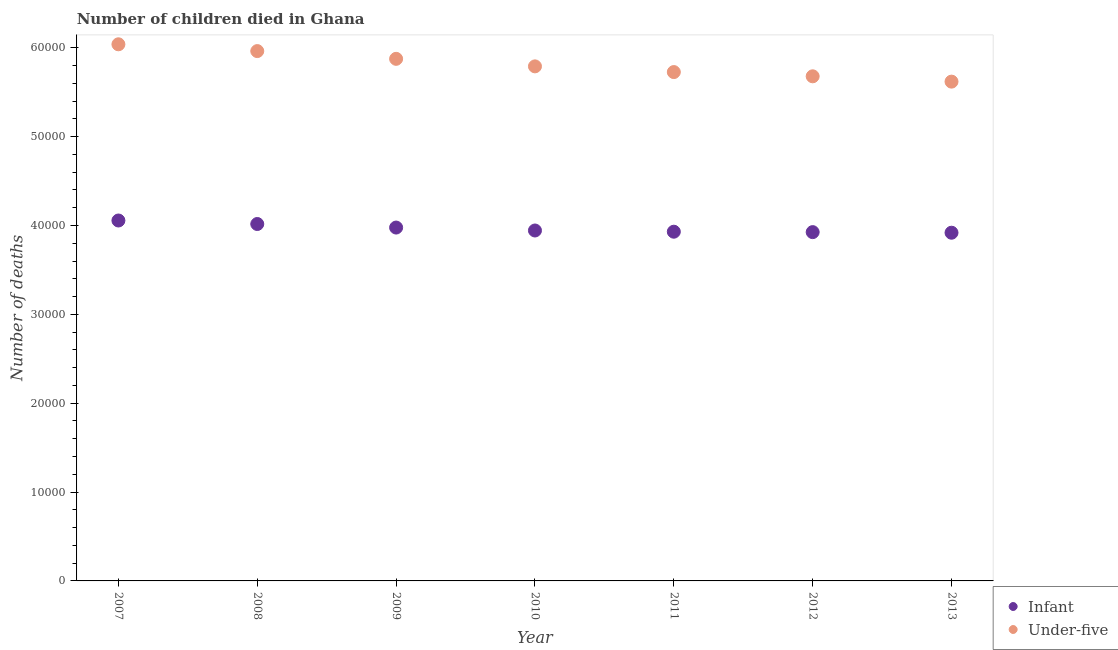How many different coloured dotlines are there?
Offer a very short reply. 2. What is the number of infant deaths in 2008?
Your response must be concise. 4.02e+04. Across all years, what is the maximum number of under-five deaths?
Ensure brevity in your answer.  6.04e+04. Across all years, what is the minimum number of infant deaths?
Provide a short and direct response. 3.92e+04. In which year was the number of infant deaths minimum?
Your answer should be compact. 2013. What is the total number of under-five deaths in the graph?
Your answer should be compact. 4.07e+05. What is the difference between the number of infant deaths in 2011 and that in 2013?
Offer a very short reply. 114. What is the difference between the number of infant deaths in 2007 and the number of under-five deaths in 2010?
Your answer should be compact. -1.73e+04. What is the average number of infant deaths per year?
Offer a very short reply. 3.97e+04. In the year 2007, what is the difference between the number of under-five deaths and number of infant deaths?
Your response must be concise. 1.98e+04. In how many years, is the number of infant deaths greater than 26000?
Your response must be concise. 7. What is the ratio of the number of under-five deaths in 2007 to that in 2011?
Your answer should be very brief. 1.05. Is the number of under-five deaths in 2007 less than that in 2010?
Ensure brevity in your answer.  No. What is the difference between the highest and the second highest number of infant deaths?
Make the answer very short. 394. What is the difference between the highest and the lowest number of under-five deaths?
Keep it short and to the point. 4202. In how many years, is the number of under-five deaths greater than the average number of under-five deaths taken over all years?
Make the answer very short. 3. Does the number of under-five deaths monotonically increase over the years?
Make the answer very short. No. Is the number of infant deaths strictly greater than the number of under-five deaths over the years?
Your answer should be very brief. No. Is the number of under-five deaths strictly less than the number of infant deaths over the years?
Your answer should be very brief. No. How many dotlines are there?
Ensure brevity in your answer.  2. How many years are there in the graph?
Offer a terse response. 7. What is the difference between two consecutive major ticks on the Y-axis?
Your response must be concise. 10000. Are the values on the major ticks of Y-axis written in scientific E-notation?
Offer a very short reply. No. Does the graph contain any zero values?
Ensure brevity in your answer.  No. Does the graph contain grids?
Ensure brevity in your answer.  No. How are the legend labels stacked?
Provide a succinct answer. Vertical. What is the title of the graph?
Offer a terse response. Number of children died in Ghana. What is the label or title of the Y-axis?
Make the answer very short. Number of deaths. What is the Number of deaths of Infant in 2007?
Your answer should be compact. 4.06e+04. What is the Number of deaths of Under-five in 2007?
Your response must be concise. 6.04e+04. What is the Number of deaths in Infant in 2008?
Your response must be concise. 4.02e+04. What is the Number of deaths in Under-five in 2008?
Offer a very short reply. 5.96e+04. What is the Number of deaths of Infant in 2009?
Your answer should be very brief. 3.98e+04. What is the Number of deaths of Under-five in 2009?
Make the answer very short. 5.88e+04. What is the Number of deaths of Infant in 2010?
Offer a very short reply. 3.94e+04. What is the Number of deaths in Under-five in 2010?
Your answer should be compact. 5.79e+04. What is the Number of deaths in Infant in 2011?
Ensure brevity in your answer.  3.93e+04. What is the Number of deaths of Under-five in 2011?
Make the answer very short. 5.73e+04. What is the Number of deaths in Infant in 2012?
Make the answer very short. 3.93e+04. What is the Number of deaths in Under-five in 2012?
Offer a terse response. 5.68e+04. What is the Number of deaths of Infant in 2013?
Make the answer very short. 3.92e+04. What is the Number of deaths of Under-five in 2013?
Your response must be concise. 5.62e+04. Across all years, what is the maximum Number of deaths in Infant?
Provide a succinct answer. 4.06e+04. Across all years, what is the maximum Number of deaths of Under-five?
Offer a terse response. 6.04e+04. Across all years, what is the minimum Number of deaths of Infant?
Your answer should be compact. 3.92e+04. Across all years, what is the minimum Number of deaths of Under-five?
Offer a terse response. 5.62e+04. What is the total Number of deaths of Infant in the graph?
Offer a very short reply. 2.78e+05. What is the total Number of deaths of Under-five in the graph?
Offer a terse response. 4.07e+05. What is the difference between the Number of deaths of Infant in 2007 and that in 2008?
Keep it short and to the point. 394. What is the difference between the Number of deaths in Under-five in 2007 and that in 2008?
Your answer should be very brief. 764. What is the difference between the Number of deaths in Infant in 2007 and that in 2009?
Offer a terse response. 794. What is the difference between the Number of deaths of Under-five in 2007 and that in 2009?
Provide a short and direct response. 1636. What is the difference between the Number of deaths in Infant in 2007 and that in 2010?
Offer a terse response. 1125. What is the difference between the Number of deaths in Under-five in 2007 and that in 2010?
Your answer should be compact. 2484. What is the difference between the Number of deaths of Infant in 2007 and that in 2011?
Keep it short and to the point. 1261. What is the difference between the Number of deaths of Under-five in 2007 and that in 2011?
Your answer should be very brief. 3126. What is the difference between the Number of deaths of Infant in 2007 and that in 2012?
Make the answer very short. 1308. What is the difference between the Number of deaths in Under-five in 2007 and that in 2012?
Offer a very short reply. 3603. What is the difference between the Number of deaths of Infant in 2007 and that in 2013?
Your answer should be very brief. 1375. What is the difference between the Number of deaths of Under-five in 2007 and that in 2013?
Keep it short and to the point. 4202. What is the difference between the Number of deaths of Under-five in 2008 and that in 2009?
Give a very brief answer. 872. What is the difference between the Number of deaths of Infant in 2008 and that in 2010?
Your answer should be compact. 731. What is the difference between the Number of deaths in Under-five in 2008 and that in 2010?
Your answer should be compact. 1720. What is the difference between the Number of deaths in Infant in 2008 and that in 2011?
Give a very brief answer. 867. What is the difference between the Number of deaths of Under-five in 2008 and that in 2011?
Make the answer very short. 2362. What is the difference between the Number of deaths in Infant in 2008 and that in 2012?
Your answer should be compact. 914. What is the difference between the Number of deaths of Under-five in 2008 and that in 2012?
Your response must be concise. 2839. What is the difference between the Number of deaths of Infant in 2008 and that in 2013?
Provide a short and direct response. 981. What is the difference between the Number of deaths in Under-five in 2008 and that in 2013?
Ensure brevity in your answer.  3438. What is the difference between the Number of deaths of Infant in 2009 and that in 2010?
Ensure brevity in your answer.  331. What is the difference between the Number of deaths of Under-five in 2009 and that in 2010?
Keep it short and to the point. 848. What is the difference between the Number of deaths in Infant in 2009 and that in 2011?
Your answer should be compact. 467. What is the difference between the Number of deaths of Under-five in 2009 and that in 2011?
Ensure brevity in your answer.  1490. What is the difference between the Number of deaths of Infant in 2009 and that in 2012?
Offer a very short reply. 514. What is the difference between the Number of deaths of Under-five in 2009 and that in 2012?
Your answer should be very brief. 1967. What is the difference between the Number of deaths of Infant in 2009 and that in 2013?
Give a very brief answer. 581. What is the difference between the Number of deaths of Under-five in 2009 and that in 2013?
Give a very brief answer. 2566. What is the difference between the Number of deaths of Infant in 2010 and that in 2011?
Provide a short and direct response. 136. What is the difference between the Number of deaths of Under-five in 2010 and that in 2011?
Give a very brief answer. 642. What is the difference between the Number of deaths in Infant in 2010 and that in 2012?
Your answer should be very brief. 183. What is the difference between the Number of deaths in Under-five in 2010 and that in 2012?
Give a very brief answer. 1119. What is the difference between the Number of deaths of Infant in 2010 and that in 2013?
Offer a very short reply. 250. What is the difference between the Number of deaths in Under-five in 2010 and that in 2013?
Offer a terse response. 1718. What is the difference between the Number of deaths of Infant in 2011 and that in 2012?
Your answer should be compact. 47. What is the difference between the Number of deaths of Under-five in 2011 and that in 2012?
Your response must be concise. 477. What is the difference between the Number of deaths in Infant in 2011 and that in 2013?
Your answer should be compact. 114. What is the difference between the Number of deaths of Under-five in 2011 and that in 2013?
Keep it short and to the point. 1076. What is the difference between the Number of deaths in Infant in 2012 and that in 2013?
Your response must be concise. 67. What is the difference between the Number of deaths in Under-five in 2012 and that in 2013?
Offer a terse response. 599. What is the difference between the Number of deaths in Infant in 2007 and the Number of deaths in Under-five in 2008?
Offer a terse response. -1.91e+04. What is the difference between the Number of deaths of Infant in 2007 and the Number of deaths of Under-five in 2009?
Keep it short and to the point. -1.82e+04. What is the difference between the Number of deaths in Infant in 2007 and the Number of deaths in Under-five in 2010?
Give a very brief answer. -1.73e+04. What is the difference between the Number of deaths of Infant in 2007 and the Number of deaths of Under-five in 2011?
Your answer should be very brief. -1.67e+04. What is the difference between the Number of deaths of Infant in 2007 and the Number of deaths of Under-five in 2012?
Your answer should be very brief. -1.62e+04. What is the difference between the Number of deaths of Infant in 2007 and the Number of deaths of Under-five in 2013?
Your answer should be very brief. -1.56e+04. What is the difference between the Number of deaths of Infant in 2008 and the Number of deaths of Under-five in 2009?
Your answer should be very brief. -1.86e+04. What is the difference between the Number of deaths of Infant in 2008 and the Number of deaths of Under-five in 2010?
Your answer should be compact. -1.77e+04. What is the difference between the Number of deaths in Infant in 2008 and the Number of deaths in Under-five in 2011?
Give a very brief answer. -1.71e+04. What is the difference between the Number of deaths of Infant in 2008 and the Number of deaths of Under-five in 2012?
Your response must be concise. -1.66e+04. What is the difference between the Number of deaths of Infant in 2008 and the Number of deaths of Under-five in 2013?
Make the answer very short. -1.60e+04. What is the difference between the Number of deaths of Infant in 2009 and the Number of deaths of Under-five in 2010?
Your answer should be compact. -1.81e+04. What is the difference between the Number of deaths in Infant in 2009 and the Number of deaths in Under-five in 2011?
Offer a terse response. -1.75e+04. What is the difference between the Number of deaths in Infant in 2009 and the Number of deaths in Under-five in 2012?
Make the answer very short. -1.70e+04. What is the difference between the Number of deaths of Infant in 2009 and the Number of deaths of Under-five in 2013?
Give a very brief answer. -1.64e+04. What is the difference between the Number of deaths of Infant in 2010 and the Number of deaths of Under-five in 2011?
Your response must be concise. -1.78e+04. What is the difference between the Number of deaths in Infant in 2010 and the Number of deaths in Under-five in 2012?
Keep it short and to the point. -1.74e+04. What is the difference between the Number of deaths in Infant in 2010 and the Number of deaths in Under-five in 2013?
Offer a very short reply. -1.68e+04. What is the difference between the Number of deaths in Infant in 2011 and the Number of deaths in Under-five in 2012?
Your response must be concise. -1.75e+04. What is the difference between the Number of deaths in Infant in 2011 and the Number of deaths in Under-five in 2013?
Your answer should be very brief. -1.69e+04. What is the difference between the Number of deaths of Infant in 2012 and the Number of deaths of Under-five in 2013?
Provide a succinct answer. -1.69e+04. What is the average Number of deaths of Infant per year?
Ensure brevity in your answer.  3.97e+04. What is the average Number of deaths in Under-five per year?
Your answer should be compact. 5.81e+04. In the year 2007, what is the difference between the Number of deaths of Infant and Number of deaths of Under-five?
Give a very brief answer. -1.98e+04. In the year 2008, what is the difference between the Number of deaths in Infant and Number of deaths in Under-five?
Your response must be concise. -1.95e+04. In the year 2009, what is the difference between the Number of deaths in Infant and Number of deaths in Under-five?
Make the answer very short. -1.90e+04. In the year 2010, what is the difference between the Number of deaths of Infant and Number of deaths of Under-five?
Provide a succinct answer. -1.85e+04. In the year 2011, what is the difference between the Number of deaths in Infant and Number of deaths in Under-five?
Give a very brief answer. -1.80e+04. In the year 2012, what is the difference between the Number of deaths of Infant and Number of deaths of Under-five?
Keep it short and to the point. -1.75e+04. In the year 2013, what is the difference between the Number of deaths in Infant and Number of deaths in Under-five?
Keep it short and to the point. -1.70e+04. What is the ratio of the Number of deaths of Infant in 2007 to that in 2008?
Make the answer very short. 1.01. What is the ratio of the Number of deaths in Under-five in 2007 to that in 2008?
Provide a succinct answer. 1.01. What is the ratio of the Number of deaths of Infant in 2007 to that in 2009?
Offer a very short reply. 1.02. What is the ratio of the Number of deaths in Under-five in 2007 to that in 2009?
Keep it short and to the point. 1.03. What is the ratio of the Number of deaths of Infant in 2007 to that in 2010?
Provide a succinct answer. 1.03. What is the ratio of the Number of deaths in Under-five in 2007 to that in 2010?
Provide a short and direct response. 1.04. What is the ratio of the Number of deaths of Infant in 2007 to that in 2011?
Ensure brevity in your answer.  1.03. What is the ratio of the Number of deaths of Under-five in 2007 to that in 2011?
Keep it short and to the point. 1.05. What is the ratio of the Number of deaths of Infant in 2007 to that in 2012?
Offer a very short reply. 1.03. What is the ratio of the Number of deaths in Under-five in 2007 to that in 2012?
Provide a succinct answer. 1.06. What is the ratio of the Number of deaths in Infant in 2007 to that in 2013?
Make the answer very short. 1.04. What is the ratio of the Number of deaths in Under-five in 2007 to that in 2013?
Offer a terse response. 1.07. What is the ratio of the Number of deaths of Infant in 2008 to that in 2009?
Give a very brief answer. 1.01. What is the ratio of the Number of deaths in Under-five in 2008 to that in 2009?
Offer a very short reply. 1.01. What is the ratio of the Number of deaths of Infant in 2008 to that in 2010?
Provide a succinct answer. 1.02. What is the ratio of the Number of deaths of Under-five in 2008 to that in 2010?
Offer a very short reply. 1.03. What is the ratio of the Number of deaths of Infant in 2008 to that in 2011?
Your response must be concise. 1.02. What is the ratio of the Number of deaths in Under-five in 2008 to that in 2011?
Provide a short and direct response. 1.04. What is the ratio of the Number of deaths of Infant in 2008 to that in 2012?
Make the answer very short. 1.02. What is the ratio of the Number of deaths in Infant in 2008 to that in 2013?
Provide a succinct answer. 1.02. What is the ratio of the Number of deaths of Under-five in 2008 to that in 2013?
Provide a succinct answer. 1.06. What is the ratio of the Number of deaths of Infant in 2009 to that in 2010?
Provide a short and direct response. 1.01. What is the ratio of the Number of deaths in Under-five in 2009 to that in 2010?
Offer a very short reply. 1.01. What is the ratio of the Number of deaths in Infant in 2009 to that in 2011?
Your answer should be compact. 1.01. What is the ratio of the Number of deaths of Under-five in 2009 to that in 2011?
Keep it short and to the point. 1.03. What is the ratio of the Number of deaths of Infant in 2009 to that in 2012?
Provide a short and direct response. 1.01. What is the ratio of the Number of deaths of Under-five in 2009 to that in 2012?
Offer a terse response. 1.03. What is the ratio of the Number of deaths in Infant in 2009 to that in 2013?
Keep it short and to the point. 1.01. What is the ratio of the Number of deaths in Under-five in 2009 to that in 2013?
Your answer should be compact. 1.05. What is the ratio of the Number of deaths of Under-five in 2010 to that in 2011?
Provide a succinct answer. 1.01. What is the ratio of the Number of deaths of Infant in 2010 to that in 2012?
Your answer should be very brief. 1. What is the ratio of the Number of deaths in Under-five in 2010 to that in 2012?
Offer a terse response. 1.02. What is the ratio of the Number of deaths in Infant in 2010 to that in 2013?
Provide a succinct answer. 1.01. What is the ratio of the Number of deaths of Under-five in 2010 to that in 2013?
Provide a succinct answer. 1.03. What is the ratio of the Number of deaths of Under-five in 2011 to that in 2012?
Offer a terse response. 1.01. What is the ratio of the Number of deaths of Infant in 2011 to that in 2013?
Your answer should be very brief. 1. What is the ratio of the Number of deaths of Under-five in 2011 to that in 2013?
Provide a succinct answer. 1.02. What is the ratio of the Number of deaths of Infant in 2012 to that in 2013?
Offer a terse response. 1. What is the ratio of the Number of deaths of Under-five in 2012 to that in 2013?
Offer a very short reply. 1.01. What is the difference between the highest and the second highest Number of deaths of Infant?
Your answer should be compact. 394. What is the difference between the highest and the second highest Number of deaths of Under-five?
Keep it short and to the point. 764. What is the difference between the highest and the lowest Number of deaths of Infant?
Provide a short and direct response. 1375. What is the difference between the highest and the lowest Number of deaths of Under-five?
Keep it short and to the point. 4202. 